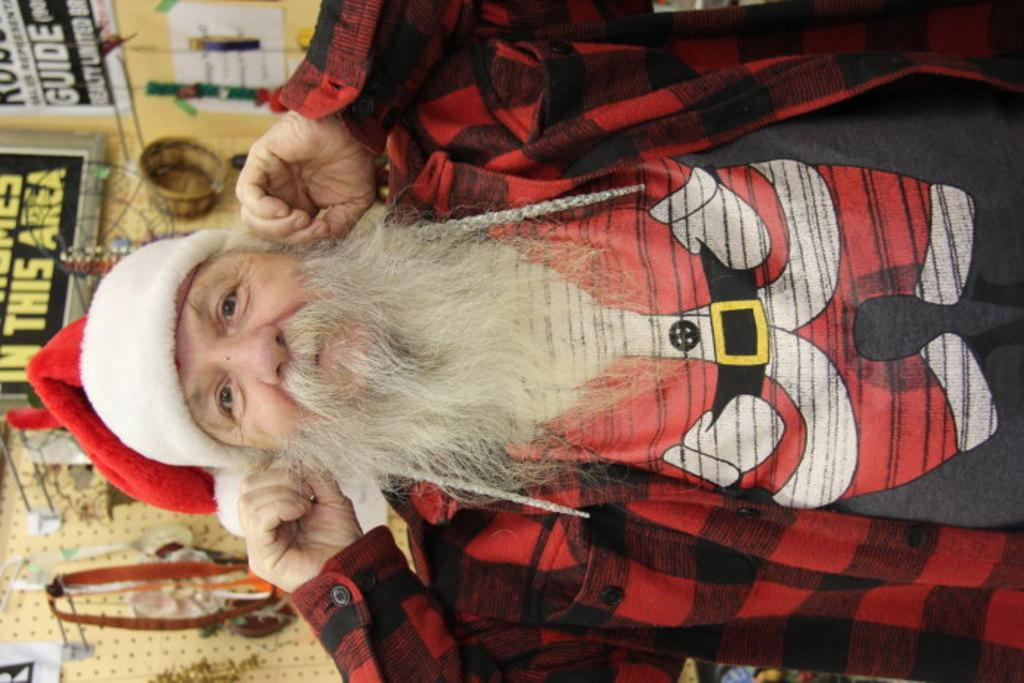What is the main subject of the image? There is a man standing in the image. What is the man wearing on his head? The man is wearing a cap on his head. What can be seen in the background of the image? There are other items on the wall in the background of the image. Can you see any mountains in the image? There are no mountains visible in the image. What type of lift is being used by the man in the image? The man is not using any lift in the image; he is simply standing. 